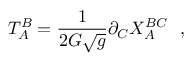Convert formula to latex. <formula><loc_0><loc_0><loc_500><loc_500>T _ { A } ^ { B } = \frac { 1 } 2 G \sqrt { g } } \partial _ { C } X _ { A } ^ { B C } ,</formula> 